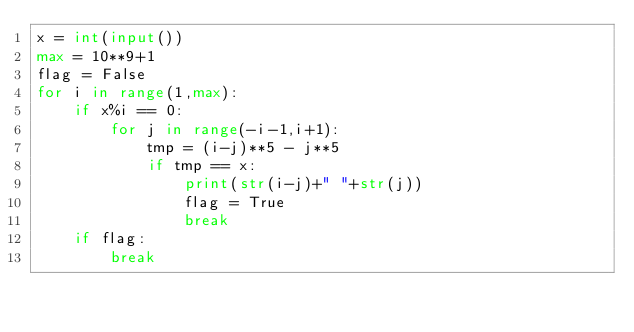Convert code to text. <code><loc_0><loc_0><loc_500><loc_500><_Python_>x = int(input())
max = 10**9+1
flag = False
for i in range(1,max):
    if x%i == 0:
        for j in range(-i-1,i+1):
            tmp = (i-j)**5 - j**5
            if tmp == x:
                print(str(i-j)+" "+str(j))
                flag = True
                break
    if flag:
        break</code> 